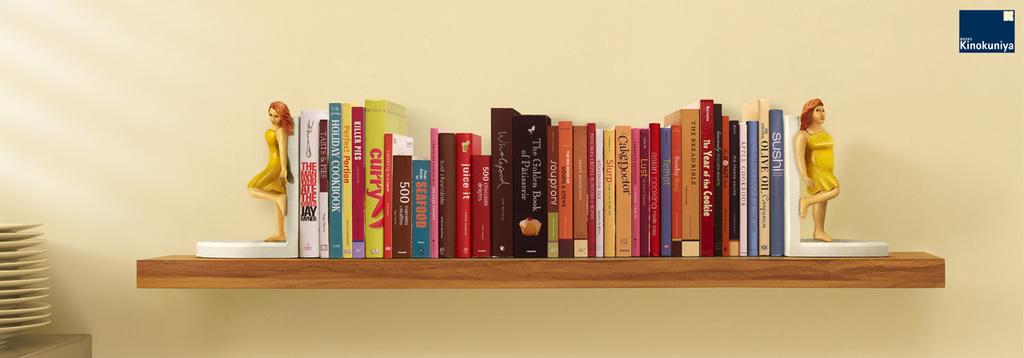What is the title of the blue book to the right?
Offer a very short reply. Sushi. 